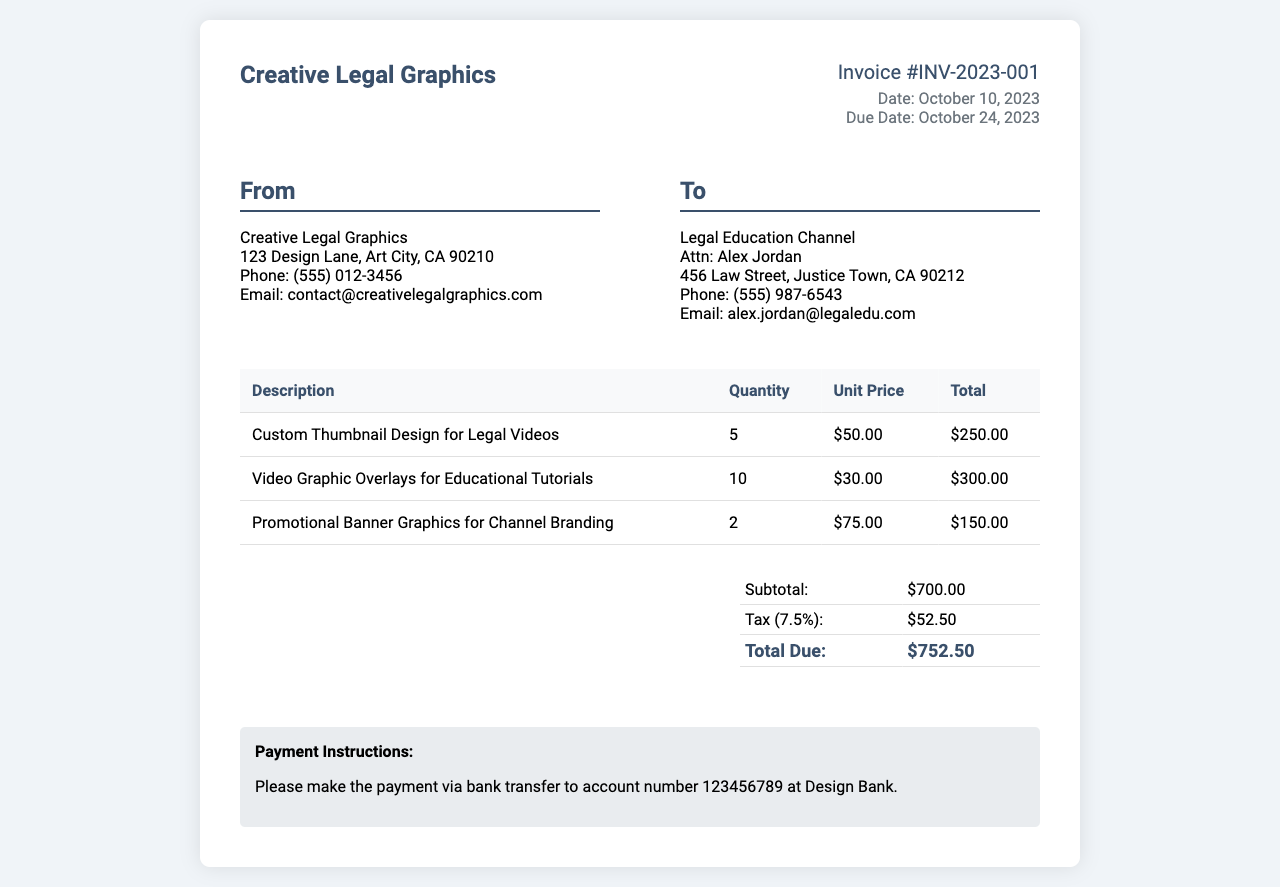What is the invoice number? The invoice number is clearly listed at the top of the document for easy reference.
Answer: INV-2023-001 Who is the service provider? The service provider's name is stated prominently in the header of the invoice.
Answer: Creative Legal Graphics What is the due date? The due date is specified to ensure timely payment.
Answer: October 24, 2023 How much is the subtotal? The subtotal is calculated from the itemized services provided in the invoice.
Answer: $700.00 What was the quantity of custom thumbnails designed? This value is found in the itemized list of services, indicating how many of that specific service were provided.
Answer: 5 What is the total due amount? The total due amount is calculated at the bottom of the invoice after considering the subtotal and tax.
Answer: $752.50 Who is the recipient of this invoice? The recipient's name and details are provided in the address section to identify where the invoice is being sent.
Answer: Legal Education Channel What is the tax rate applied? The tax rate is mentioned in relation to the subtotal and is necessary for calculating the total due.
Answer: 7.5% How many video graphics overlays were provided? This quantity is found in the detailed table of services listed in the invoice.
Answer: 10 What payment method is specified? It is essential to know how to proceed with the payment after reviewing the invoice.
Answer: Bank transfer 